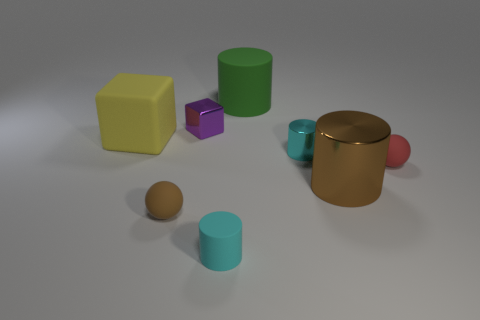What number of other things are there of the same material as the tiny block
Give a very brief answer. 2. Is the number of rubber cubes in front of the cyan rubber object less than the number of big purple balls?
Give a very brief answer. No. Is the shape of the brown matte object the same as the tiny cyan matte object?
Make the answer very short. No. There is a rubber sphere that is on the right side of the small cyan thing that is left of the tiny cyan object that is behind the tiny brown matte ball; what size is it?
Keep it short and to the point. Small. There is a brown object that is the same shape as the large green matte object; what material is it?
Make the answer very short. Metal. How big is the ball that is on the left side of the purple metal block in front of the big matte cylinder?
Give a very brief answer. Small. The large matte block is what color?
Your answer should be very brief. Yellow. How many cyan matte objects are behind the small shiny thing that is behind the yellow rubber cube?
Make the answer very short. 0. There is a small rubber sphere that is left of the small red rubber thing; is there a cyan thing that is on the right side of it?
Provide a succinct answer. Yes. Are there any big green cylinders on the right side of the brown ball?
Ensure brevity in your answer.  Yes. 